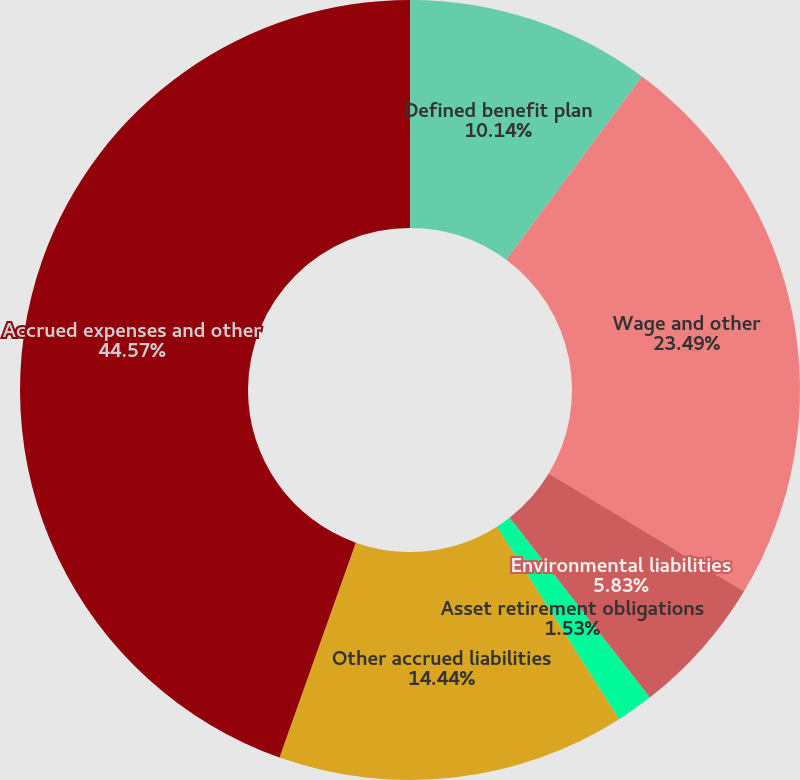Convert chart. <chart><loc_0><loc_0><loc_500><loc_500><pie_chart><fcel>Defined benefit plan<fcel>Wage and other<fcel>Environmental liabilities<fcel>Asset retirement obligations<fcel>Other accrued liabilities<fcel>Accrued expenses and other<nl><fcel>10.14%<fcel>23.49%<fcel>5.83%<fcel>1.53%<fcel>14.44%<fcel>44.57%<nl></chart> 